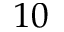<formula> <loc_0><loc_0><loc_500><loc_500>1 0</formula> 